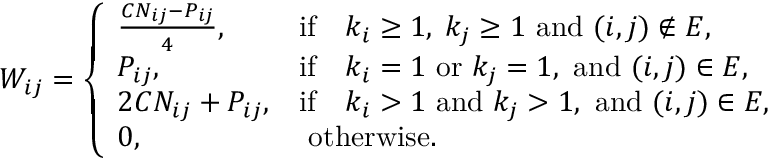Convert formula to latex. <formula><loc_0><loc_0><loc_500><loc_500>W _ { i j } = \left \{ \begin{array} { l l } { \frac { C N _ { i j } - P _ { i j } } { 4 } , } & { i f \quad k _ { i } \geq 1 , \, k _ { j } \geq 1 a n d ( i , j ) \notin E , } \\ { P _ { i j } , } & { i f \quad k _ { i } = 1 o r k _ { j } = 1 , a n d ( i , j ) \in E , } \\ { 2 C N _ { i j } + P _ { i j } , } & { i f \quad k _ { i } > 1 a n d k _ { j } > 1 , a n d ( i , j ) \in E , } \\ { 0 , } & { o t h e r w i s e . } \end{array}</formula> 